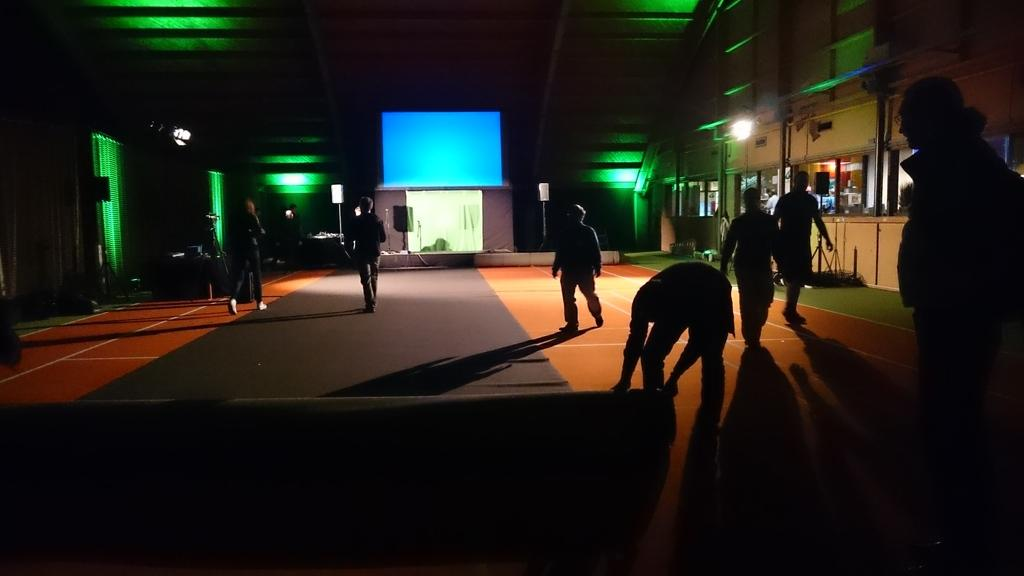What is the lighting condition in the room in the image? The room in the image is dark. What type of flooring is present in the image? There is a carpet on the floor in the image. What are the people in the image doing? There are people walking in the image. Can you describe the source of light in the image? There are lights visible in the image. What type of bun is being held by the person in the image? There is no bun present in the image; the people are walking without any visible objects in their hands. Can you describe the zipper on the gate in the image? There is no gate or zipper present in the image; the focus is on the dark room, carpet, people walking, and visible lights. 